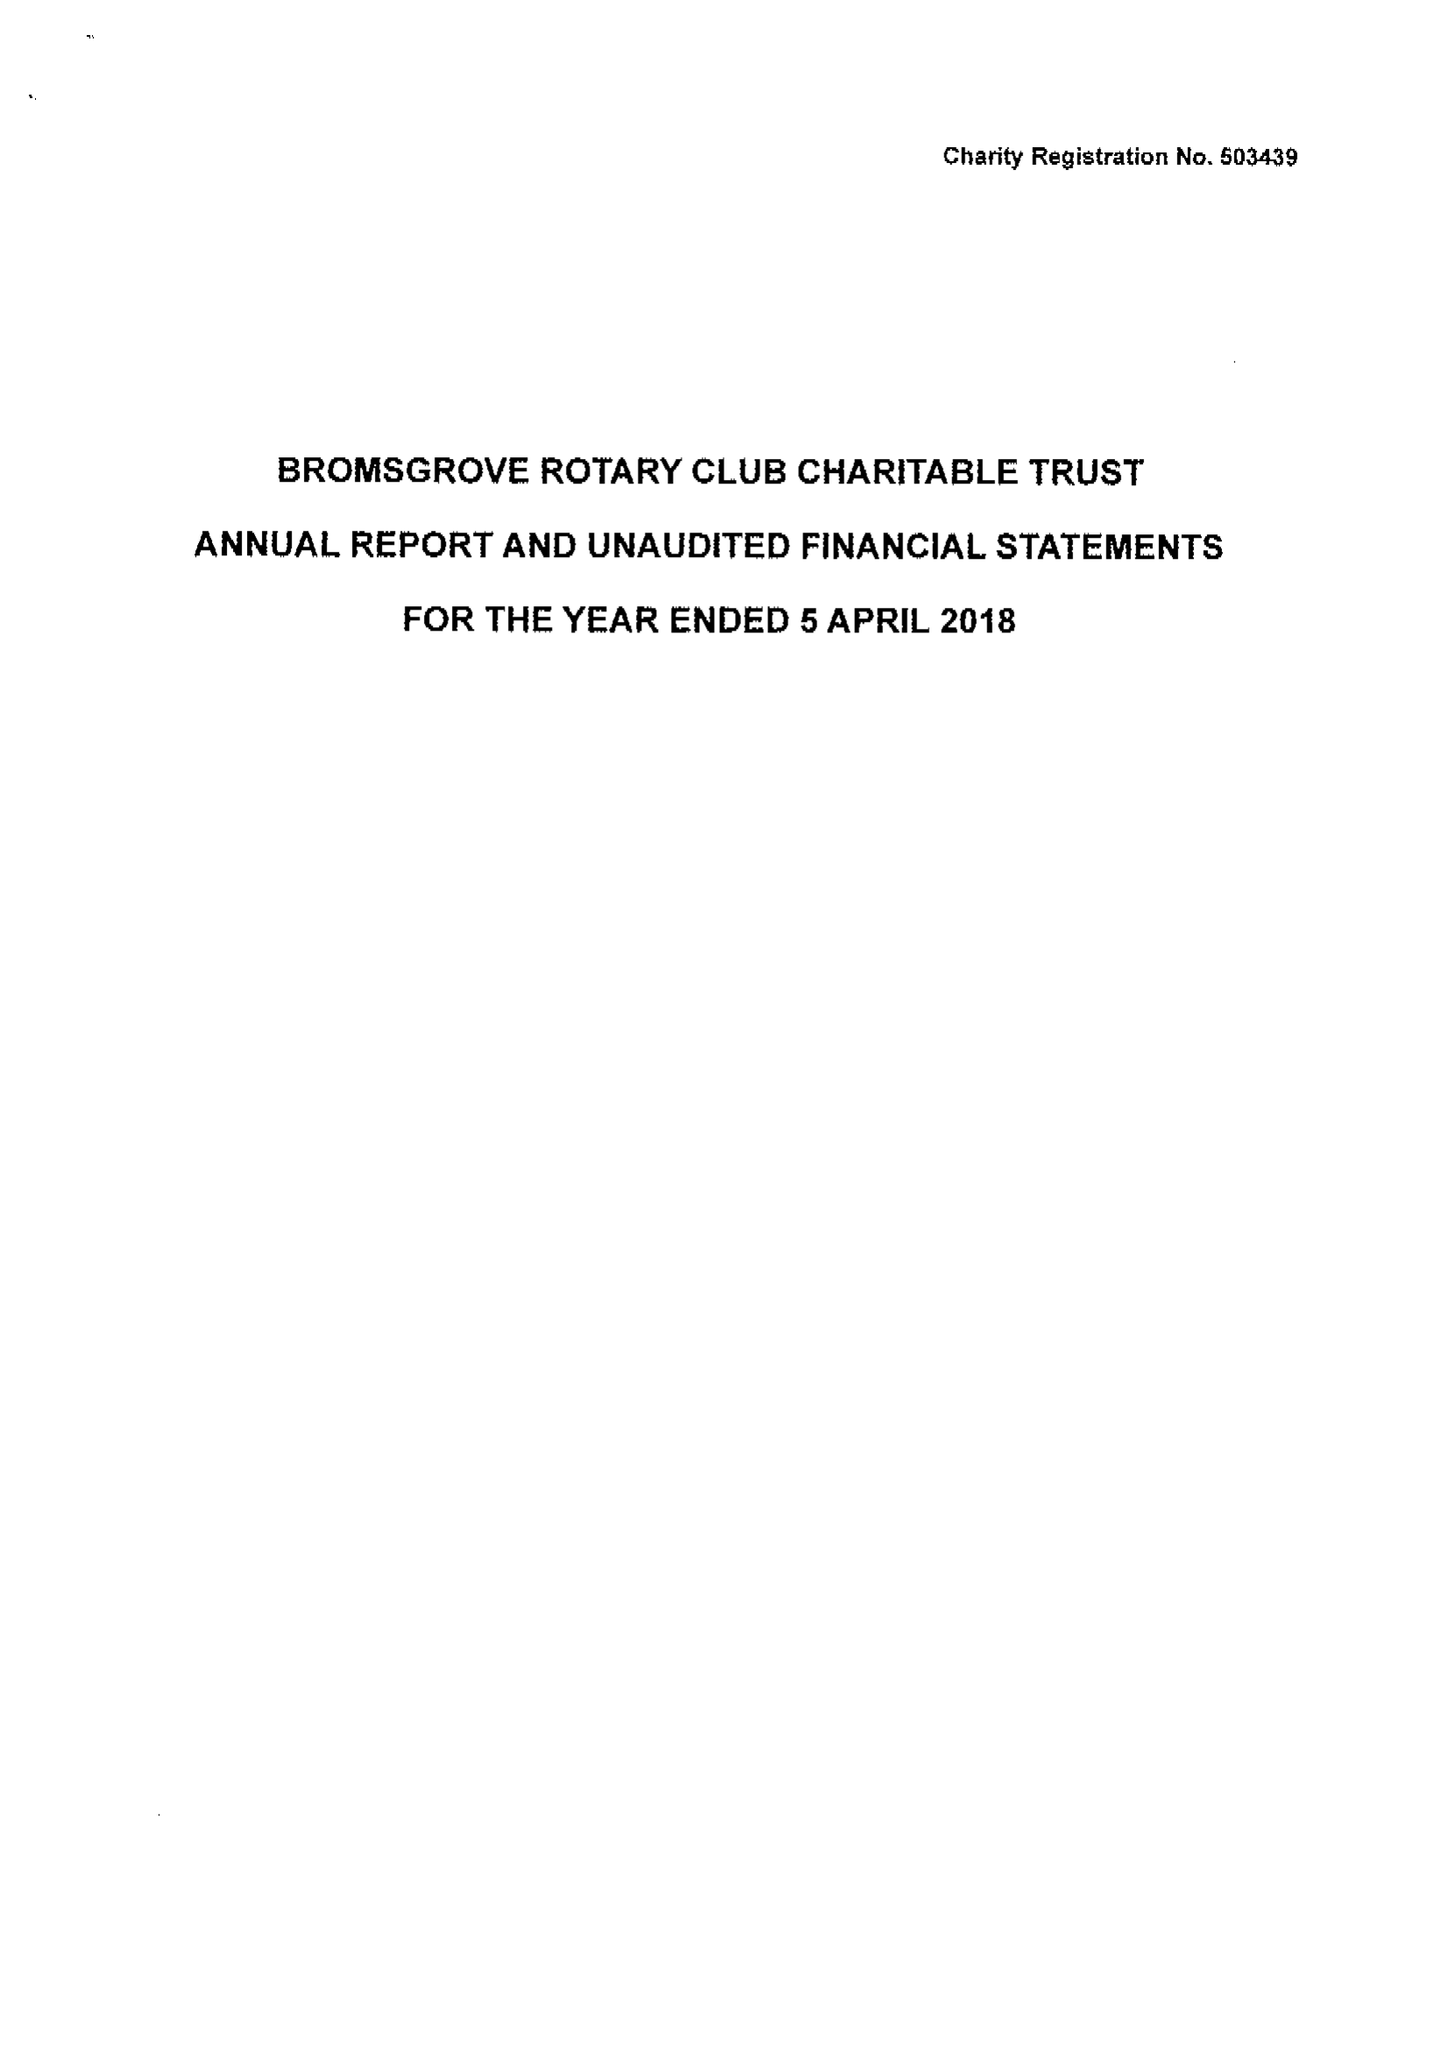What is the value for the income_annually_in_british_pounds?
Answer the question using a single word or phrase. 35581.00 